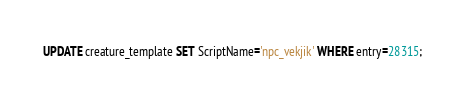Convert code to text. <code><loc_0><loc_0><loc_500><loc_500><_SQL_>UPDATE creature_template SET ScriptName='npc_vekjik' WHERE entry=28315;
</code> 